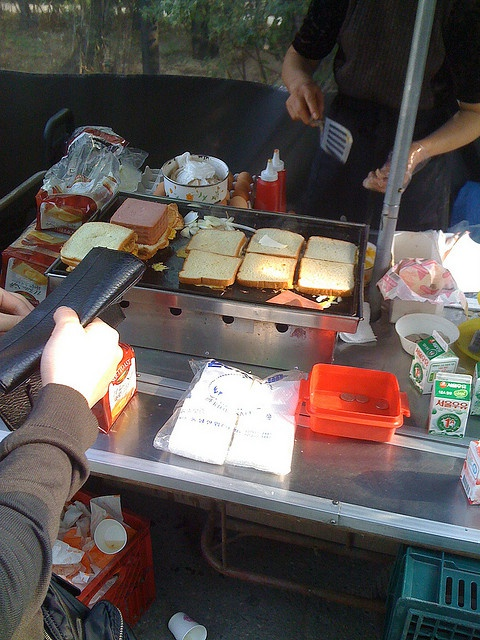Describe the objects in this image and their specific colors. I can see people in black, gray, and maroon tones, people in black, gray, and white tones, chair in black, gray, and blue tones, handbag in black, gray, and darkblue tones, and bowl in black, darkgray, and gray tones in this image. 